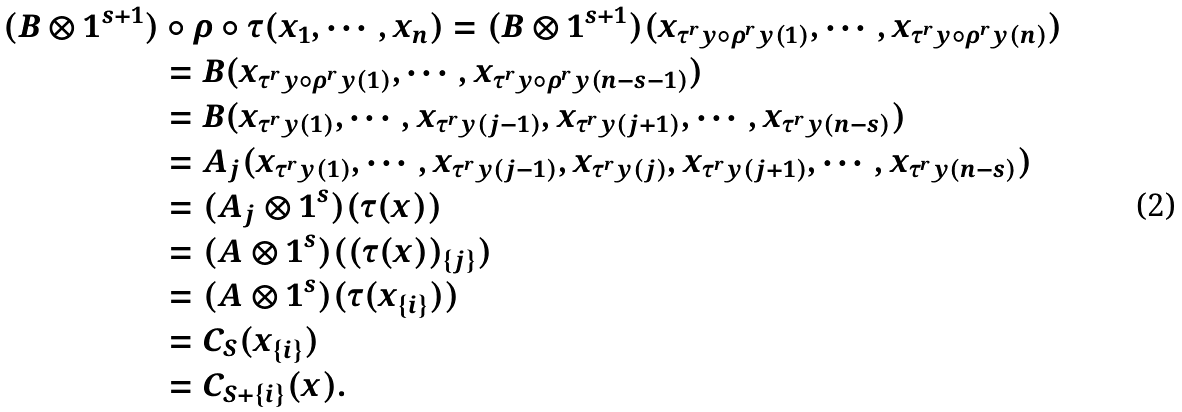<formula> <loc_0><loc_0><loc_500><loc_500>( B \otimes 1 ^ { s + 1 } ) & \circ \rho \circ \tau ( x _ { 1 } , \cdots , x _ { n } ) = ( B \otimes 1 ^ { s + 1 } ) ( x _ { \tau ^ { r } y \circ \rho ^ { r } y ( 1 ) } , \cdots , x _ { \tau ^ { r } y \circ \rho ^ { r } y ( n ) } ) \\ & = B ( x _ { \tau ^ { r } y \circ \rho ^ { r } y ( 1 ) } , \cdots , x _ { \tau ^ { r } y \circ \rho ^ { r } y ( n - s - 1 ) } ) \\ & = B ( x _ { \tau ^ { r } y ( 1 ) } , \cdots , x _ { \tau ^ { r } y ( j - 1 ) } , x _ { \tau ^ { r } y ( j + 1 ) } , \cdots , x _ { \tau ^ { r } y ( n - s ) } ) \\ & = A _ { j } ( x _ { \tau ^ { r } y ( 1 ) } , \cdots , x _ { \tau ^ { r } y ( j - 1 ) } , x _ { \tau ^ { r } y ( j ) } , x _ { \tau ^ { r } y ( j + 1 ) } , \cdots , x _ { \tau ^ { r } y ( n - s ) } ) \\ & = ( A _ { j } \otimes 1 ^ { s } ) ( \tau ( x ) ) \\ & = ( A \otimes 1 ^ { s } ) ( ( \tau ( x ) ) _ { \{ j \} } ) \\ & = ( A \otimes 1 ^ { s } ) ( \tau ( x _ { \{ i \} } ) ) \\ & = C _ { S } ( x _ { \{ i \} } ) \\ & = C _ { S + \{ i \} } ( x ) .</formula> 